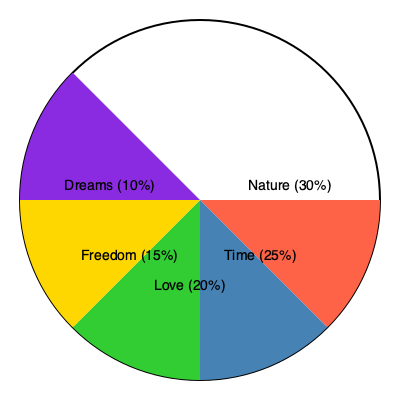Based on the pie chart depicting the frequency of specific imagery in Bob Dylan's lyrics, which two categories of imagery collectively account for 55% of the total and how might this reflect Dylan's poetic sensibilities? To answer this question, we need to analyze the pie chart and consider Bob Dylan's poetic themes:

1. Identify the two largest segments:
   - Nature: 30%
   - Time: 25%

2. Calculate the sum of these two segments:
   30% + 25% = 55%

3. Interpret the significance:
   a) Nature imagery (30%):
      - Reflects Dylan's connection to the natural world
      - Often used as metaphors for human experiences or emotions
      - Examples: "Blowin' in the Wind," "The Times They Are A-Changin'"

   b) Time imagery (25%):
      - Indicates Dylan's preoccupation with temporality and change
      - Used to explore themes of personal growth, societal shifts, and the human condition
      - Examples: "Forever Young," "My Back Pages"

4. Consider Dylan's poetic sensibilities:
   - The combination of nature and time imagery (55%) suggests a focus on the cyclical nature of existence and the relationship between humans and their environment.
   - This reflects Dylan's tendency to use concrete, vivid imagery to explore abstract concepts and universal truths.
   - The emphasis on these themes aligns with Dylan's role as a voice of social conscience and philosophical reflection in popular music.

5. Poetic techniques:
   - Dylan often employs extended metaphors, drawing parallels between natural phenomena and human experiences.
   - His use of time-related imagery creates a sense of urgency or nostalgia, depending on the context.
   - The interplay between nature and time in his lyrics often results in rich, multi-layered meanings that reward close analysis.
Answer: Nature (30%) and Time (25%), reflecting Dylan's focus on cyclical existence and human-environment relationships. 